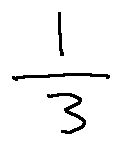<formula> <loc_0><loc_0><loc_500><loc_500>\frac { 1 } { 3 }</formula> 